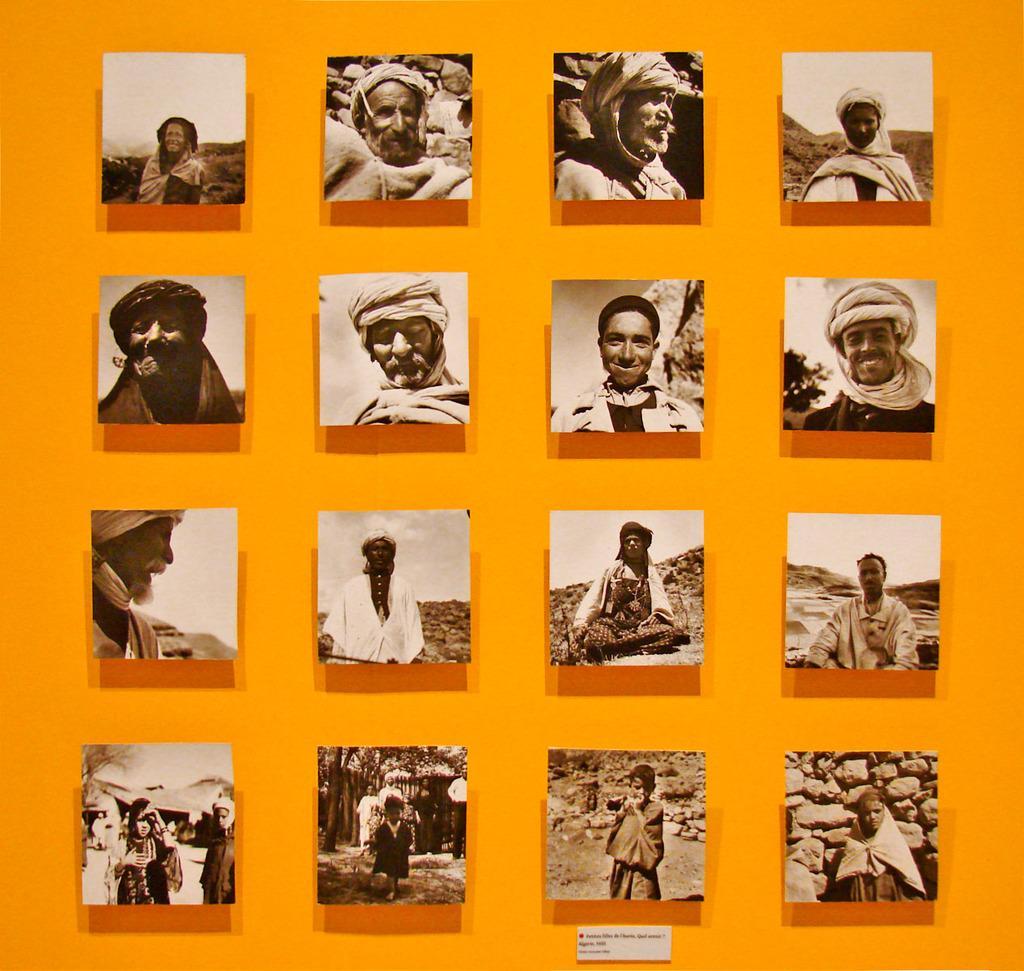Please provide a concise description of this image. This picture describes about college of few images, in this we can find few people. 